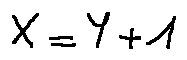<formula> <loc_0><loc_0><loc_500><loc_500>X = Y + 1</formula> 